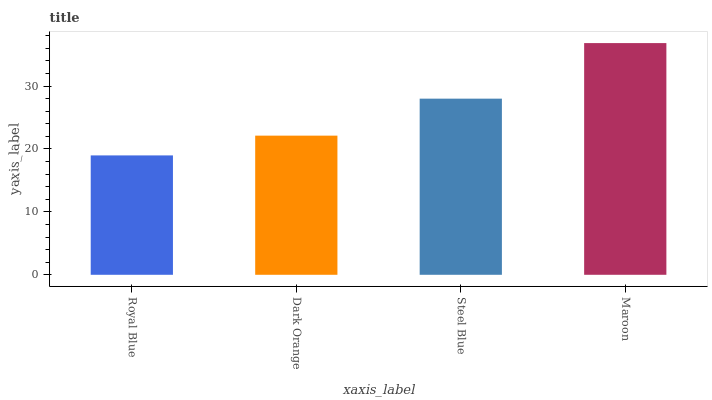Is Dark Orange the minimum?
Answer yes or no. No. Is Dark Orange the maximum?
Answer yes or no. No. Is Dark Orange greater than Royal Blue?
Answer yes or no. Yes. Is Royal Blue less than Dark Orange?
Answer yes or no. Yes. Is Royal Blue greater than Dark Orange?
Answer yes or no. No. Is Dark Orange less than Royal Blue?
Answer yes or no. No. Is Steel Blue the high median?
Answer yes or no. Yes. Is Dark Orange the low median?
Answer yes or no. Yes. Is Maroon the high median?
Answer yes or no. No. Is Royal Blue the low median?
Answer yes or no. No. 